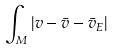<formula> <loc_0><loc_0><loc_500><loc_500>\int _ { M } | v - \bar { v } - \bar { v } _ { E } |</formula> 